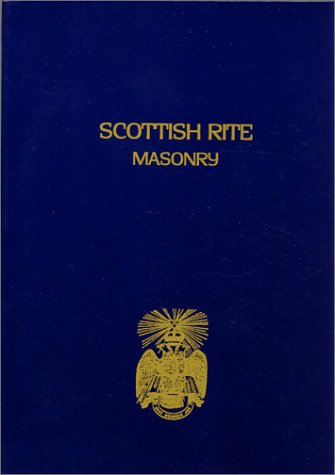Who wrote this book?
Answer the question using a single word or phrase. John Blanchard What is the title of this book? Scottish Rite Masonry Vol.2 What type of book is this? Religion & Spirituality Is this book related to Religion & Spirituality? Yes Is this book related to Teen & Young Adult? No 